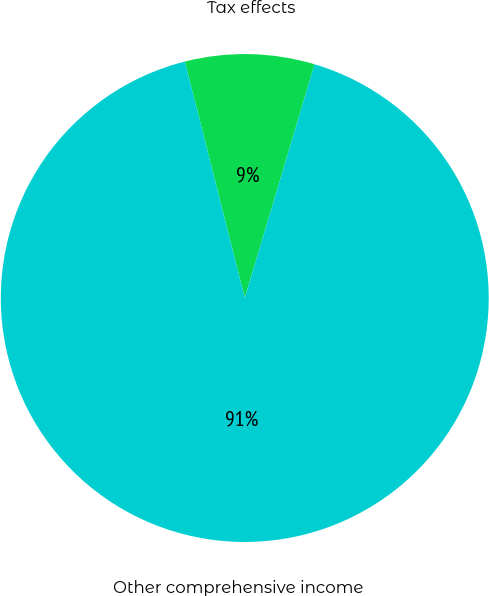<chart> <loc_0><loc_0><loc_500><loc_500><pie_chart><fcel>Tax effects<fcel>Other comprehensive income<nl><fcel>8.57%<fcel>91.43%<nl></chart> 